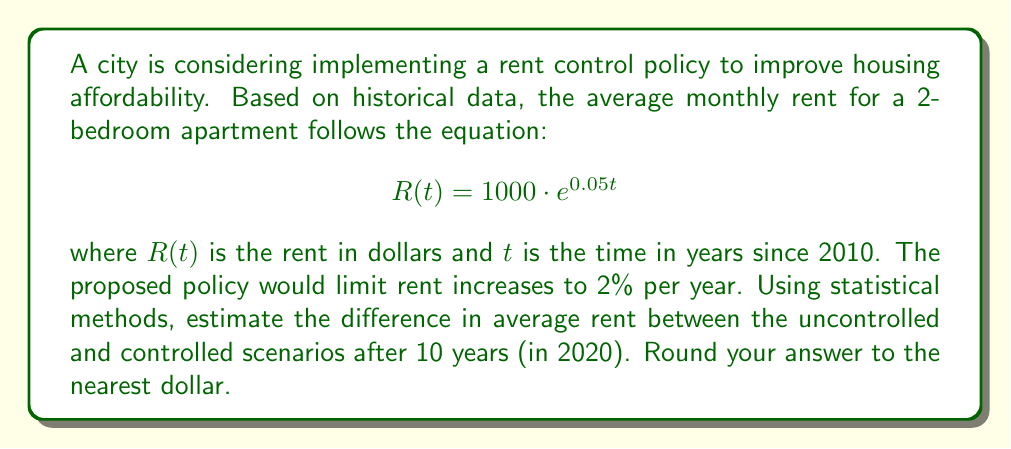Solve this math problem. To solve this problem, we'll follow these steps:

1. Calculate the uncontrolled rent after 10 years:
   $$R(10) = 1000 \cdot e^{0.05 \cdot 10}$$
   $$R(10) = 1000 \cdot e^{0.5}$$
   $$R(10) = 1000 \cdot 1.6487$$
   $$R(10) = 1648.72$$

2. Calculate the controlled rent after 10 years:
   With a 2% annual increase, we can use the compound interest formula:
   $$R_{controlled}(10) = 1000 \cdot (1 + 0.02)^{10}$$
   $$R_{controlled}(10) = 1000 \cdot 1.2190$$
   $$R_{controlled}(10) = 1218.99$$

3. Calculate the difference between uncontrolled and controlled rents:
   $$\text{Difference} = R(10) - R_{controlled}(10)$$
   $$\text{Difference} = 1648.72 - 1218.99$$
   $$\text{Difference} = 429.73$$

4. Round to the nearest dollar:
   $$\text{Rounded difference} = 430$$

This analysis demonstrates that the rent control policy would result in a significant difference in average rent after 10 years, potentially improving housing affordability for residents.
Answer: $430 